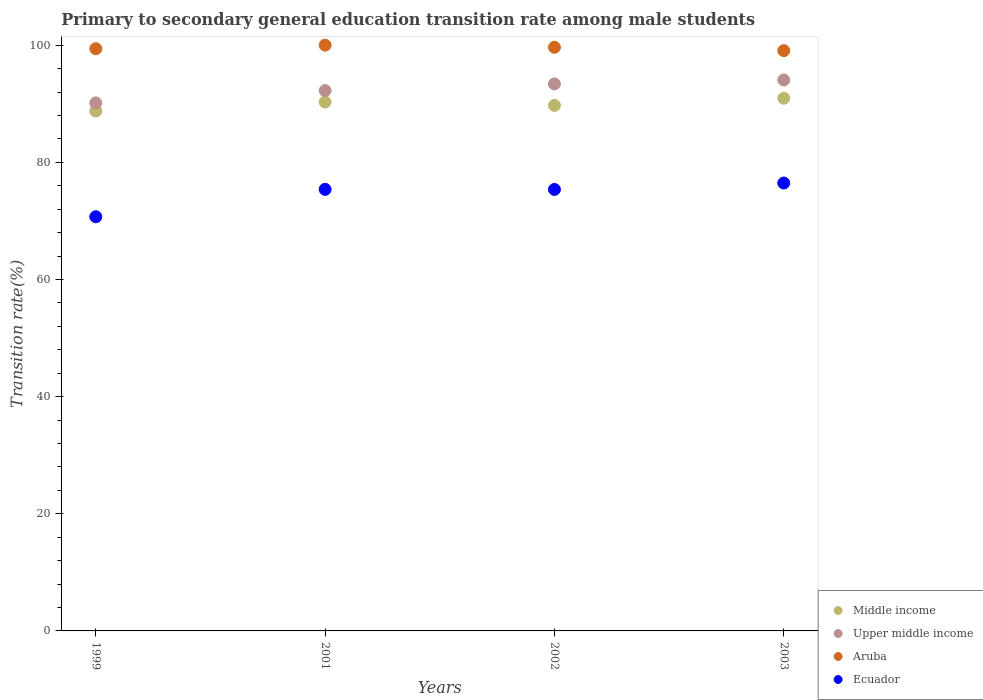How many different coloured dotlines are there?
Provide a short and direct response. 4. Is the number of dotlines equal to the number of legend labels?
Your answer should be very brief. Yes. What is the transition rate in Upper middle income in 1999?
Your answer should be very brief. 90.14. Across all years, what is the maximum transition rate in Middle income?
Offer a very short reply. 90.94. Across all years, what is the minimum transition rate in Ecuador?
Offer a very short reply. 70.71. What is the total transition rate in Middle income in the graph?
Your answer should be very brief. 359.7. What is the difference between the transition rate in Ecuador in 2001 and that in 2003?
Ensure brevity in your answer.  -1.08. What is the difference between the transition rate in Aruba in 1999 and the transition rate in Upper middle income in 2001?
Give a very brief answer. 7.15. What is the average transition rate in Middle income per year?
Give a very brief answer. 89.92. In the year 1999, what is the difference between the transition rate in Upper middle income and transition rate in Middle income?
Your answer should be compact. 1.38. What is the ratio of the transition rate in Aruba in 2001 to that in 2003?
Your answer should be compact. 1.01. What is the difference between the highest and the second highest transition rate in Upper middle income?
Give a very brief answer. 0.67. What is the difference between the highest and the lowest transition rate in Aruba?
Provide a short and direct response. 0.93. Is the sum of the transition rate in Aruba in 1999 and 2002 greater than the maximum transition rate in Ecuador across all years?
Your answer should be compact. Yes. Is it the case that in every year, the sum of the transition rate in Middle income and transition rate in Upper middle income  is greater than the sum of transition rate in Ecuador and transition rate in Aruba?
Your answer should be compact. No. Is it the case that in every year, the sum of the transition rate in Middle income and transition rate in Ecuador  is greater than the transition rate in Aruba?
Your answer should be very brief. Yes. Does the transition rate in Upper middle income monotonically increase over the years?
Your answer should be compact. Yes. Is the transition rate in Aruba strictly greater than the transition rate in Middle income over the years?
Offer a very short reply. Yes. Is the transition rate in Middle income strictly less than the transition rate in Upper middle income over the years?
Your response must be concise. Yes. How many dotlines are there?
Provide a succinct answer. 4. How many years are there in the graph?
Provide a short and direct response. 4. Does the graph contain any zero values?
Keep it short and to the point. No. Does the graph contain grids?
Provide a short and direct response. No. How are the legend labels stacked?
Your response must be concise. Vertical. What is the title of the graph?
Ensure brevity in your answer.  Primary to secondary general education transition rate among male students. What is the label or title of the Y-axis?
Ensure brevity in your answer.  Transition rate(%). What is the Transition rate(%) in Middle income in 1999?
Provide a succinct answer. 88.76. What is the Transition rate(%) in Upper middle income in 1999?
Provide a short and direct response. 90.14. What is the Transition rate(%) in Aruba in 1999?
Keep it short and to the point. 99.39. What is the Transition rate(%) of Ecuador in 1999?
Offer a terse response. 70.71. What is the Transition rate(%) in Middle income in 2001?
Give a very brief answer. 90.3. What is the Transition rate(%) of Upper middle income in 2001?
Make the answer very short. 92.25. What is the Transition rate(%) in Aruba in 2001?
Make the answer very short. 100. What is the Transition rate(%) in Ecuador in 2001?
Ensure brevity in your answer.  75.38. What is the Transition rate(%) in Middle income in 2002?
Offer a terse response. 89.71. What is the Transition rate(%) of Upper middle income in 2002?
Provide a succinct answer. 93.39. What is the Transition rate(%) in Aruba in 2002?
Provide a succinct answer. 99.63. What is the Transition rate(%) of Ecuador in 2002?
Keep it short and to the point. 75.37. What is the Transition rate(%) of Middle income in 2003?
Give a very brief answer. 90.94. What is the Transition rate(%) of Upper middle income in 2003?
Make the answer very short. 94.06. What is the Transition rate(%) of Aruba in 2003?
Your response must be concise. 99.07. What is the Transition rate(%) of Ecuador in 2003?
Ensure brevity in your answer.  76.46. Across all years, what is the maximum Transition rate(%) in Middle income?
Provide a short and direct response. 90.94. Across all years, what is the maximum Transition rate(%) in Upper middle income?
Provide a succinct answer. 94.06. Across all years, what is the maximum Transition rate(%) of Aruba?
Keep it short and to the point. 100. Across all years, what is the maximum Transition rate(%) in Ecuador?
Your answer should be compact. 76.46. Across all years, what is the minimum Transition rate(%) of Middle income?
Offer a very short reply. 88.76. Across all years, what is the minimum Transition rate(%) in Upper middle income?
Ensure brevity in your answer.  90.14. Across all years, what is the minimum Transition rate(%) in Aruba?
Give a very brief answer. 99.07. Across all years, what is the minimum Transition rate(%) of Ecuador?
Offer a very short reply. 70.71. What is the total Transition rate(%) of Middle income in the graph?
Offer a terse response. 359.7. What is the total Transition rate(%) in Upper middle income in the graph?
Make the answer very short. 369.84. What is the total Transition rate(%) of Aruba in the graph?
Your answer should be very brief. 398.1. What is the total Transition rate(%) of Ecuador in the graph?
Your answer should be compact. 297.92. What is the difference between the Transition rate(%) of Middle income in 1999 and that in 2001?
Your response must be concise. -1.54. What is the difference between the Transition rate(%) of Upper middle income in 1999 and that in 2001?
Your answer should be compact. -2.11. What is the difference between the Transition rate(%) of Aruba in 1999 and that in 2001?
Your answer should be very brief. -0.61. What is the difference between the Transition rate(%) in Ecuador in 1999 and that in 2001?
Make the answer very short. -4.68. What is the difference between the Transition rate(%) of Middle income in 1999 and that in 2002?
Offer a very short reply. -0.95. What is the difference between the Transition rate(%) of Upper middle income in 1999 and that in 2002?
Offer a terse response. -3.25. What is the difference between the Transition rate(%) in Aruba in 1999 and that in 2002?
Your response must be concise. -0.24. What is the difference between the Transition rate(%) of Ecuador in 1999 and that in 2002?
Ensure brevity in your answer.  -4.66. What is the difference between the Transition rate(%) in Middle income in 1999 and that in 2003?
Your response must be concise. -2.18. What is the difference between the Transition rate(%) in Upper middle income in 1999 and that in 2003?
Your answer should be very brief. -3.92. What is the difference between the Transition rate(%) in Aruba in 1999 and that in 2003?
Provide a succinct answer. 0.32. What is the difference between the Transition rate(%) in Ecuador in 1999 and that in 2003?
Keep it short and to the point. -5.76. What is the difference between the Transition rate(%) in Middle income in 2001 and that in 2002?
Provide a short and direct response. 0.59. What is the difference between the Transition rate(%) of Upper middle income in 2001 and that in 2002?
Keep it short and to the point. -1.14. What is the difference between the Transition rate(%) in Aruba in 2001 and that in 2002?
Provide a short and direct response. 0.37. What is the difference between the Transition rate(%) of Ecuador in 2001 and that in 2002?
Make the answer very short. 0.01. What is the difference between the Transition rate(%) of Middle income in 2001 and that in 2003?
Offer a very short reply. -0.64. What is the difference between the Transition rate(%) of Upper middle income in 2001 and that in 2003?
Provide a short and direct response. -1.81. What is the difference between the Transition rate(%) in Ecuador in 2001 and that in 2003?
Give a very brief answer. -1.08. What is the difference between the Transition rate(%) of Middle income in 2002 and that in 2003?
Your answer should be compact. -1.23. What is the difference between the Transition rate(%) in Upper middle income in 2002 and that in 2003?
Keep it short and to the point. -0.67. What is the difference between the Transition rate(%) in Aruba in 2002 and that in 2003?
Keep it short and to the point. 0.56. What is the difference between the Transition rate(%) of Ecuador in 2002 and that in 2003?
Offer a very short reply. -1.09. What is the difference between the Transition rate(%) in Middle income in 1999 and the Transition rate(%) in Upper middle income in 2001?
Give a very brief answer. -3.49. What is the difference between the Transition rate(%) in Middle income in 1999 and the Transition rate(%) in Aruba in 2001?
Offer a terse response. -11.24. What is the difference between the Transition rate(%) of Middle income in 1999 and the Transition rate(%) of Ecuador in 2001?
Make the answer very short. 13.37. What is the difference between the Transition rate(%) of Upper middle income in 1999 and the Transition rate(%) of Aruba in 2001?
Your answer should be very brief. -9.86. What is the difference between the Transition rate(%) in Upper middle income in 1999 and the Transition rate(%) in Ecuador in 2001?
Make the answer very short. 14.76. What is the difference between the Transition rate(%) in Aruba in 1999 and the Transition rate(%) in Ecuador in 2001?
Give a very brief answer. 24.01. What is the difference between the Transition rate(%) in Middle income in 1999 and the Transition rate(%) in Upper middle income in 2002?
Make the answer very short. -4.63. What is the difference between the Transition rate(%) of Middle income in 1999 and the Transition rate(%) of Aruba in 2002?
Ensure brevity in your answer.  -10.88. What is the difference between the Transition rate(%) in Middle income in 1999 and the Transition rate(%) in Ecuador in 2002?
Give a very brief answer. 13.39. What is the difference between the Transition rate(%) of Upper middle income in 1999 and the Transition rate(%) of Aruba in 2002?
Offer a terse response. -9.49. What is the difference between the Transition rate(%) of Upper middle income in 1999 and the Transition rate(%) of Ecuador in 2002?
Make the answer very short. 14.77. What is the difference between the Transition rate(%) in Aruba in 1999 and the Transition rate(%) in Ecuador in 2002?
Your answer should be compact. 24.02. What is the difference between the Transition rate(%) in Middle income in 1999 and the Transition rate(%) in Upper middle income in 2003?
Your answer should be very brief. -5.3. What is the difference between the Transition rate(%) in Middle income in 1999 and the Transition rate(%) in Aruba in 2003?
Give a very brief answer. -10.31. What is the difference between the Transition rate(%) of Middle income in 1999 and the Transition rate(%) of Ecuador in 2003?
Give a very brief answer. 12.29. What is the difference between the Transition rate(%) of Upper middle income in 1999 and the Transition rate(%) of Aruba in 2003?
Give a very brief answer. -8.93. What is the difference between the Transition rate(%) in Upper middle income in 1999 and the Transition rate(%) in Ecuador in 2003?
Ensure brevity in your answer.  13.68. What is the difference between the Transition rate(%) of Aruba in 1999 and the Transition rate(%) of Ecuador in 2003?
Your response must be concise. 22.93. What is the difference between the Transition rate(%) of Middle income in 2001 and the Transition rate(%) of Upper middle income in 2002?
Make the answer very short. -3.1. What is the difference between the Transition rate(%) in Middle income in 2001 and the Transition rate(%) in Aruba in 2002?
Your response must be concise. -9.34. What is the difference between the Transition rate(%) of Middle income in 2001 and the Transition rate(%) of Ecuador in 2002?
Your answer should be compact. 14.93. What is the difference between the Transition rate(%) of Upper middle income in 2001 and the Transition rate(%) of Aruba in 2002?
Keep it short and to the point. -7.39. What is the difference between the Transition rate(%) in Upper middle income in 2001 and the Transition rate(%) in Ecuador in 2002?
Provide a short and direct response. 16.88. What is the difference between the Transition rate(%) of Aruba in 2001 and the Transition rate(%) of Ecuador in 2002?
Provide a short and direct response. 24.63. What is the difference between the Transition rate(%) of Middle income in 2001 and the Transition rate(%) of Upper middle income in 2003?
Give a very brief answer. -3.76. What is the difference between the Transition rate(%) in Middle income in 2001 and the Transition rate(%) in Aruba in 2003?
Your answer should be very brief. -8.77. What is the difference between the Transition rate(%) of Middle income in 2001 and the Transition rate(%) of Ecuador in 2003?
Your answer should be compact. 13.83. What is the difference between the Transition rate(%) of Upper middle income in 2001 and the Transition rate(%) of Aruba in 2003?
Provide a succinct answer. -6.82. What is the difference between the Transition rate(%) of Upper middle income in 2001 and the Transition rate(%) of Ecuador in 2003?
Provide a succinct answer. 15.78. What is the difference between the Transition rate(%) in Aruba in 2001 and the Transition rate(%) in Ecuador in 2003?
Keep it short and to the point. 23.54. What is the difference between the Transition rate(%) of Middle income in 2002 and the Transition rate(%) of Upper middle income in 2003?
Offer a very short reply. -4.35. What is the difference between the Transition rate(%) in Middle income in 2002 and the Transition rate(%) in Aruba in 2003?
Your response must be concise. -9.36. What is the difference between the Transition rate(%) of Middle income in 2002 and the Transition rate(%) of Ecuador in 2003?
Provide a short and direct response. 13.25. What is the difference between the Transition rate(%) of Upper middle income in 2002 and the Transition rate(%) of Aruba in 2003?
Your response must be concise. -5.68. What is the difference between the Transition rate(%) of Upper middle income in 2002 and the Transition rate(%) of Ecuador in 2003?
Provide a succinct answer. 16.93. What is the difference between the Transition rate(%) of Aruba in 2002 and the Transition rate(%) of Ecuador in 2003?
Keep it short and to the point. 23.17. What is the average Transition rate(%) in Middle income per year?
Provide a succinct answer. 89.92. What is the average Transition rate(%) in Upper middle income per year?
Offer a very short reply. 92.46. What is the average Transition rate(%) in Aruba per year?
Provide a succinct answer. 99.52. What is the average Transition rate(%) in Ecuador per year?
Your response must be concise. 74.48. In the year 1999, what is the difference between the Transition rate(%) in Middle income and Transition rate(%) in Upper middle income?
Provide a short and direct response. -1.38. In the year 1999, what is the difference between the Transition rate(%) of Middle income and Transition rate(%) of Aruba?
Your response must be concise. -10.64. In the year 1999, what is the difference between the Transition rate(%) in Middle income and Transition rate(%) in Ecuador?
Offer a terse response. 18.05. In the year 1999, what is the difference between the Transition rate(%) in Upper middle income and Transition rate(%) in Aruba?
Make the answer very short. -9.25. In the year 1999, what is the difference between the Transition rate(%) in Upper middle income and Transition rate(%) in Ecuador?
Your answer should be compact. 19.43. In the year 1999, what is the difference between the Transition rate(%) in Aruba and Transition rate(%) in Ecuador?
Your response must be concise. 28.69. In the year 2001, what is the difference between the Transition rate(%) in Middle income and Transition rate(%) in Upper middle income?
Your answer should be very brief. -1.95. In the year 2001, what is the difference between the Transition rate(%) in Middle income and Transition rate(%) in Aruba?
Ensure brevity in your answer.  -9.7. In the year 2001, what is the difference between the Transition rate(%) in Middle income and Transition rate(%) in Ecuador?
Your answer should be compact. 14.91. In the year 2001, what is the difference between the Transition rate(%) of Upper middle income and Transition rate(%) of Aruba?
Keep it short and to the point. -7.75. In the year 2001, what is the difference between the Transition rate(%) of Upper middle income and Transition rate(%) of Ecuador?
Give a very brief answer. 16.86. In the year 2001, what is the difference between the Transition rate(%) of Aruba and Transition rate(%) of Ecuador?
Your answer should be compact. 24.62. In the year 2002, what is the difference between the Transition rate(%) of Middle income and Transition rate(%) of Upper middle income?
Your answer should be compact. -3.68. In the year 2002, what is the difference between the Transition rate(%) of Middle income and Transition rate(%) of Aruba?
Offer a very short reply. -9.93. In the year 2002, what is the difference between the Transition rate(%) in Middle income and Transition rate(%) in Ecuador?
Provide a succinct answer. 14.34. In the year 2002, what is the difference between the Transition rate(%) of Upper middle income and Transition rate(%) of Aruba?
Make the answer very short. -6.24. In the year 2002, what is the difference between the Transition rate(%) in Upper middle income and Transition rate(%) in Ecuador?
Keep it short and to the point. 18.02. In the year 2002, what is the difference between the Transition rate(%) in Aruba and Transition rate(%) in Ecuador?
Offer a very short reply. 24.27. In the year 2003, what is the difference between the Transition rate(%) in Middle income and Transition rate(%) in Upper middle income?
Ensure brevity in your answer.  -3.12. In the year 2003, what is the difference between the Transition rate(%) of Middle income and Transition rate(%) of Aruba?
Make the answer very short. -8.13. In the year 2003, what is the difference between the Transition rate(%) in Middle income and Transition rate(%) in Ecuador?
Your response must be concise. 14.48. In the year 2003, what is the difference between the Transition rate(%) in Upper middle income and Transition rate(%) in Aruba?
Provide a short and direct response. -5.01. In the year 2003, what is the difference between the Transition rate(%) in Upper middle income and Transition rate(%) in Ecuador?
Your answer should be very brief. 17.6. In the year 2003, what is the difference between the Transition rate(%) of Aruba and Transition rate(%) of Ecuador?
Make the answer very short. 22.61. What is the ratio of the Transition rate(%) of Middle income in 1999 to that in 2001?
Provide a short and direct response. 0.98. What is the ratio of the Transition rate(%) in Upper middle income in 1999 to that in 2001?
Offer a terse response. 0.98. What is the ratio of the Transition rate(%) in Ecuador in 1999 to that in 2001?
Offer a terse response. 0.94. What is the ratio of the Transition rate(%) in Upper middle income in 1999 to that in 2002?
Your response must be concise. 0.97. What is the ratio of the Transition rate(%) in Aruba in 1999 to that in 2002?
Give a very brief answer. 1. What is the ratio of the Transition rate(%) in Ecuador in 1999 to that in 2002?
Make the answer very short. 0.94. What is the ratio of the Transition rate(%) in Upper middle income in 1999 to that in 2003?
Give a very brief answer. 0.96. What is the ratio of the Transition rate(%) in Aruba in 1999 to that in 2003?
Give a very brief answer. 1. What is the ratio of the Transition rate(%) in Ecuador in 1999 to that in 2003?
Offer a very short reply. 0.92. What is the ratio of the Transition rate(%) in Middle income in 2001 to that in 2002?
Your answer should be compact. 1.01. What is the ratio of the Transition rate(%) in Upper middle income in 2001 to that in 2002?
Ensure brevity in your answer.  0.99. What is the ratio of the Transition rate(%) in Ecuador in 2001 to that in 2002?
Your answer should be very brief. 1. What is the ratio of the Transition rate(%) of Middle income in 2001 to that in 2003?
Offer a very short reply. 0.99. What is the ratio of the Transition rate(%) in Upper middle income in 2001 to that in 2003?
Keep it short and to the point. 0.98. What is the ratio of the Transition rate(%) in Aruba in 2001 to that in 2003?
Offer a terse response. 1.01. What is the ratio of the Transition rate(%) in Ecuador in 2001 to that in 2003?
Offer a very short reply. 0.99. What is the ratio of the Transition rate(%) of Middle income in 2002 to that in 2003?
Give a very brief answer. 0.99. What is the ratio of the Transition rate(%) of Upper middle income in 2002 to that in 2003?
Your answer should be very brief. 0.99. What is the ratio of the Transition rate(%) in Aruba in 2002 to that in 2003?
Your answer should be compact. 1.01. What is the ratio of the Transition rate(%) in Ecuador in 2002 to that in 2003?
Your answer should be very brief. 0.99. What is the difference between the highest and the second highest Transition rate(%) in Middle income?
Make the answer very short. 0.64. What is the difference between the highest and the second highest Transition rate(%) of Upper middle income?
Make the answer very short. 0.67. What is the difference between the highest and the second highest Transition rate(%) of Aruba?
Ensure brevity in your answer.  0.37. What is the difference between the highest and the second highest Transition rate(%) of Ecuador?
Make the answer very short. 1.08. What is the difference between the highest and the lowest Transition rate(%) in Middle income?
Your answer should be compact. 2.18. What is the difference between the highest and the lowest Transition rate(%) of Upper middle income?
Provide a succinct answer. 3.92. What is the difference between the highest and the lowest Transition rate(%) in Aruba?
Provide a succinct answer. 0.93. What is the difference between the highest and the lowest Transition rate(%) of Ecuador?
Give a very brief answer. 5.76. 